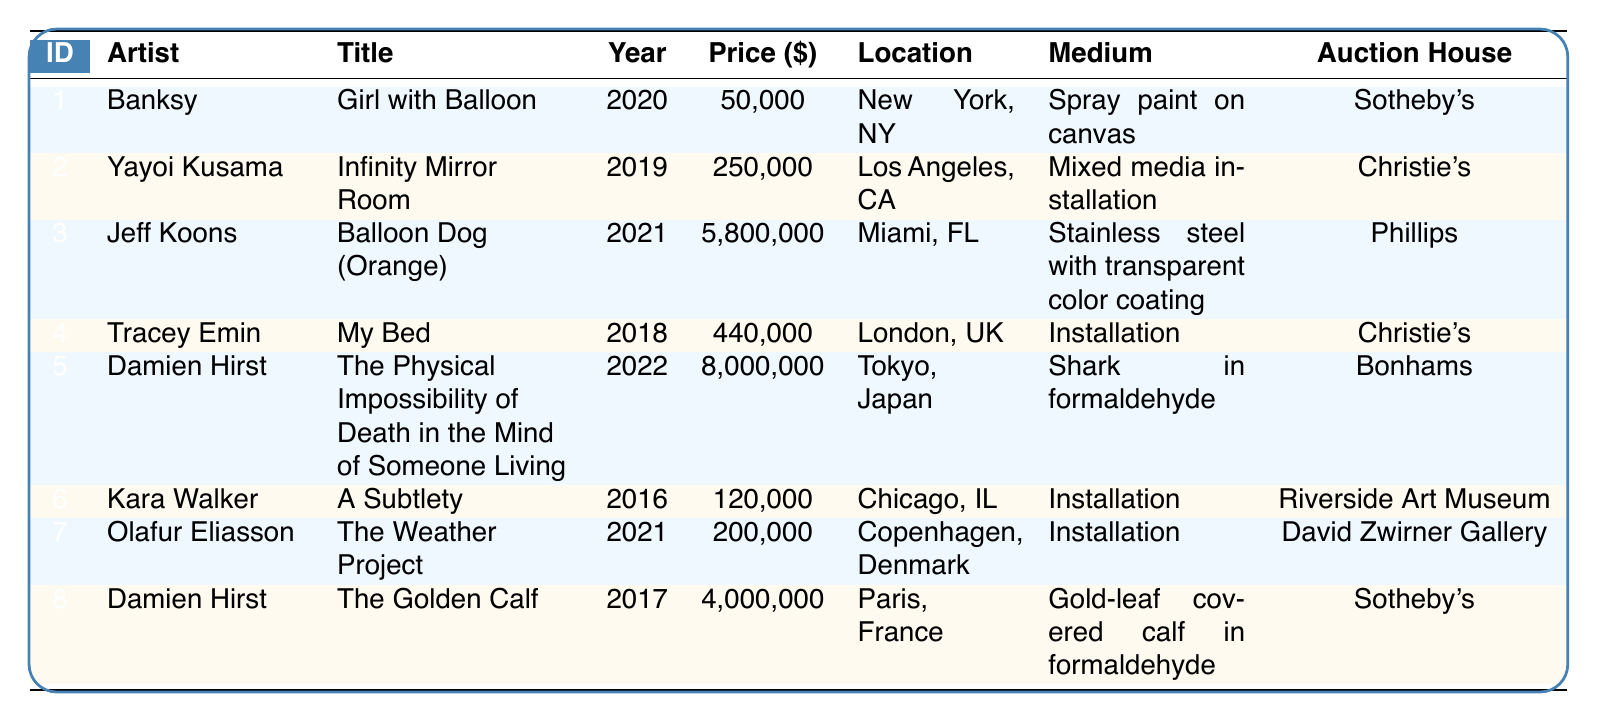What is the title of the artwork acquired by Damien Hirst in 2022? Referring to the table, Damien Hirst is associated with the acquisition date of 2022, and the title of that artwork is found in the same row.
Answer: The Physical Impossibility of Death in the Mind of Someone Living Which auction house sold Olafur Eliasson's artwork? Looking at the table, the row corresponding to Olafur Eliasson shows that the auction house listed is David Zwirner Gallery.
Answer: David Zwirner Gallery How many artworks were acquired in 2021? By checking the table, artworks acquired in 2021 include one by Jeff Koons and one by Olafur Eliasson. Therefore, there are two artworks.
Answer: 2 What is the total acquisition price of the artworks created by Damien Hirst? In the table, Damien Hirst has two artworks: one priced at 8,000,000 and another at 4,000,000. Adding these gives 8,000,000 + 4,000,000 = 12,000,000.
Answer: 12,000,000 Was "My Bed" acquired after 2020? The table shows that "My Bed" was acquired in 2018, which is before 2020. Therefore, the answer is no.
Answer: No What is the median acquisition price of the artworks listed? First, list the acquisition prices: 50000, 250000, 5800000, 440000, 8000000, 120000, 200000, 4000000. Sorting these gives: 50000, 120000, 250000, 200000, 440000, 4000000, 5800000, 8000000. The median is the average of the 4th and 5th values (200000 and 440000), which is (200000 + 440000)/2 = 320000.
Answer: 320000 Which artist has the highest single artwork acquisition price? From the table, checking the acquisition prices, Damien Hirst's artwork at 8,000,000 is the highest among all listed prices.
Answer: Damien Hirst How many artworks were acquired in a location outside the USA? The table indicates artworks in Tokyo (Damien Hirst), London (Tracey Emin), and Paris (Damien Hirst). Therefore, there are three artworks acquired outside the USA.
Answer: 3 Is "Infinity Mirror Room" by Yayoi Kusama the most expensive artwork in the list? Comparing the acquisition prices, "Infinity Mirror Room" costs 250,000, while the highest artwork (Damien Hirst's) is priced at 8,000,000. Hence, it is not the most expensive.
Answer: No 